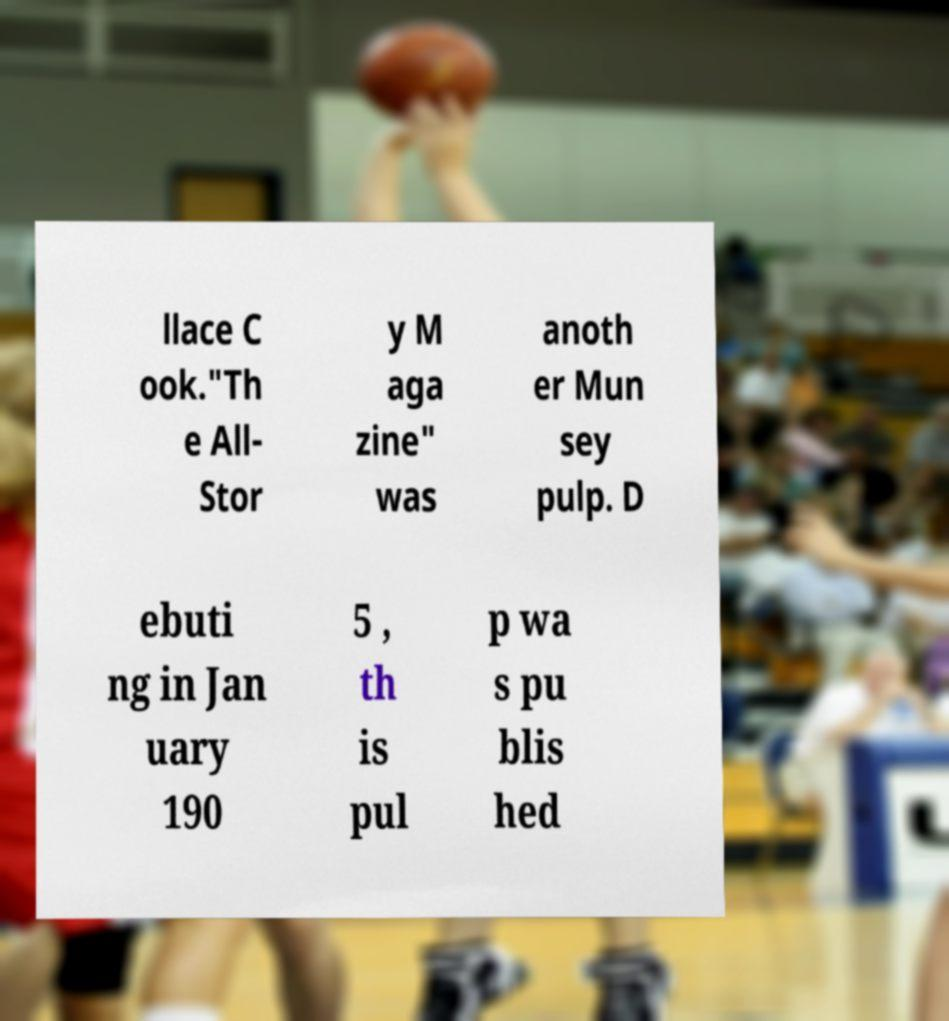What messages or text are displayed in this image? I need them in a readable, typed format. llace C ook."Th e All- Stor y M aga zine" was anoth er Mun sey pulp. D ebuti ng in Jan uary 190 5 , th is pul p wa s pu blis hed 